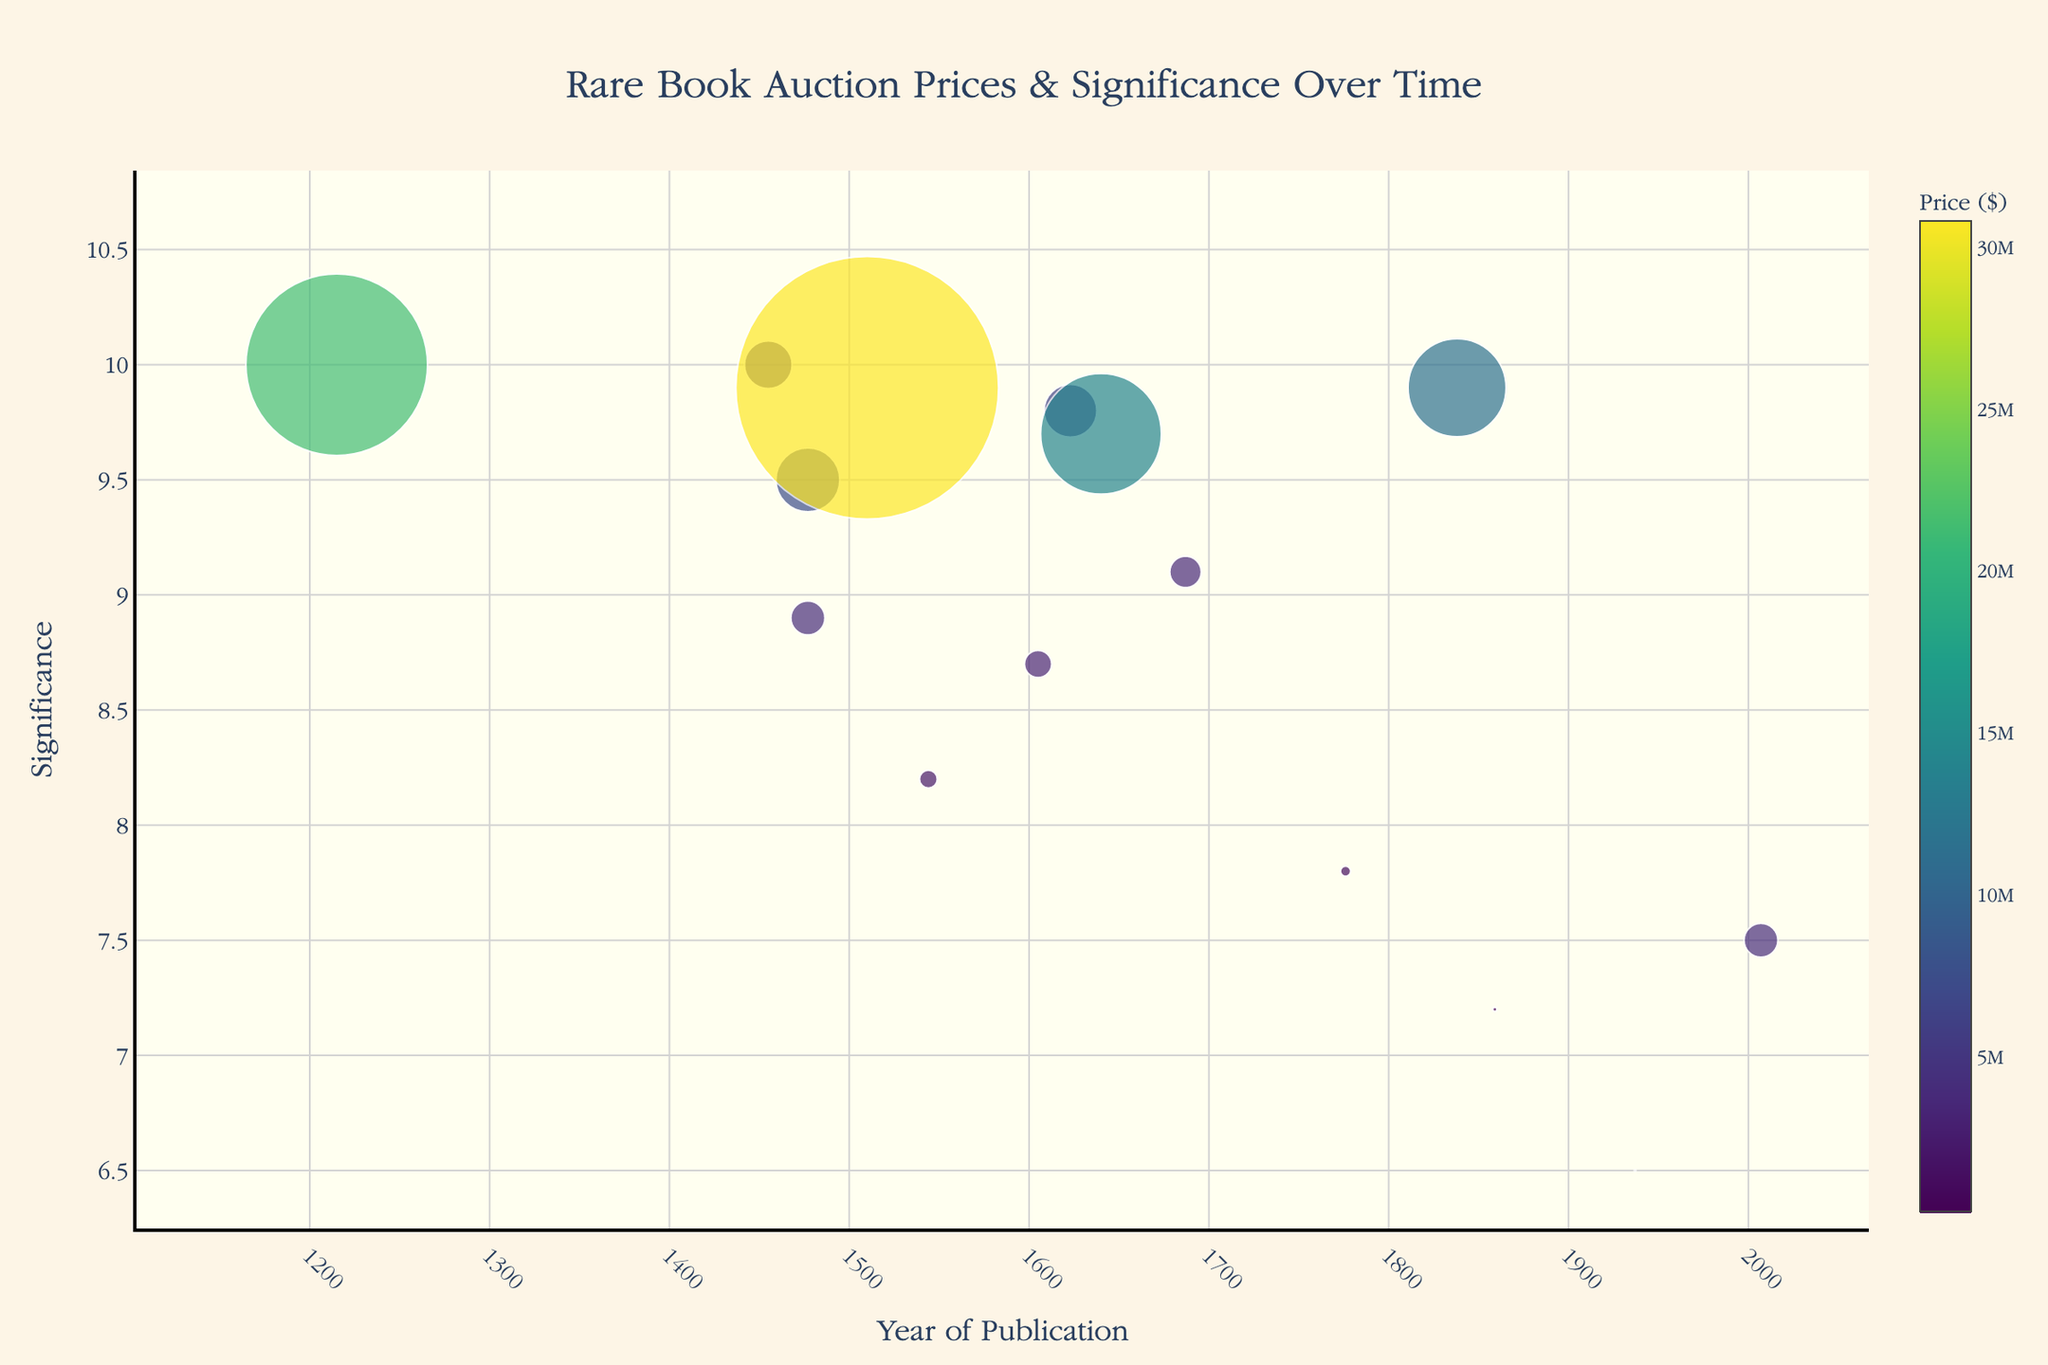What's the title of the plot? Look for the title text at the top of the plot to identify its content.
Answer: Rare Book Auction Prices & Significance Over Time What's the color of the marker for the highest-priced book? Identify the book with the highest price and observe the marker's color associated with it in the plot.
Answer: Yellow Which book has the highest significance score? Compare the significance scores along the y-axis and find the highest value.
Answer: Magna Carta How many books have a significance score above 9? Count the data points that have a significance score greater than 9 by looking at the y-axis values.
Answer: 7 What's the average price of books published before 1500? Identify the books published before 1500, sum their prices, and divide by the number of these books. Specifically, Gutenberg Bible, The Canterbury Tales, and Magna Carta: (5600000 + 7500000 + 21300000) / 3 = 11166666.67
Answer: 11,166,667 Which book has a significance score very close to 8 but is less than 8? Locate the significance scores around 8 and determine which one is slightly below it.
Answer: The Wealth of Nations Is there a correlation between the age of the book and its significance score? Examine the trend in significance scores relative to the years, noting both horizontal (year) and vertical (significance) patterns.
Answer: Yes What is the significance score of 'Codex Leicester'? Locate the 'Codex Leicester' data point on the plot and read the significance value off the y-axis.
Answer: 9.9 Which book has the lowest price and what is its significance? Identify the data point with the smallest marker size and check the hover info for its significance value.
Answer: The Hobbit, 6.5 Which two books published in the 1600s have the closest significance scores and what are they? Compare all books published in the 1600s and find the two with the most similar significance scores.
Answer: Don Quixote and The Bay Psalm Book (8.7 and 9.7) 